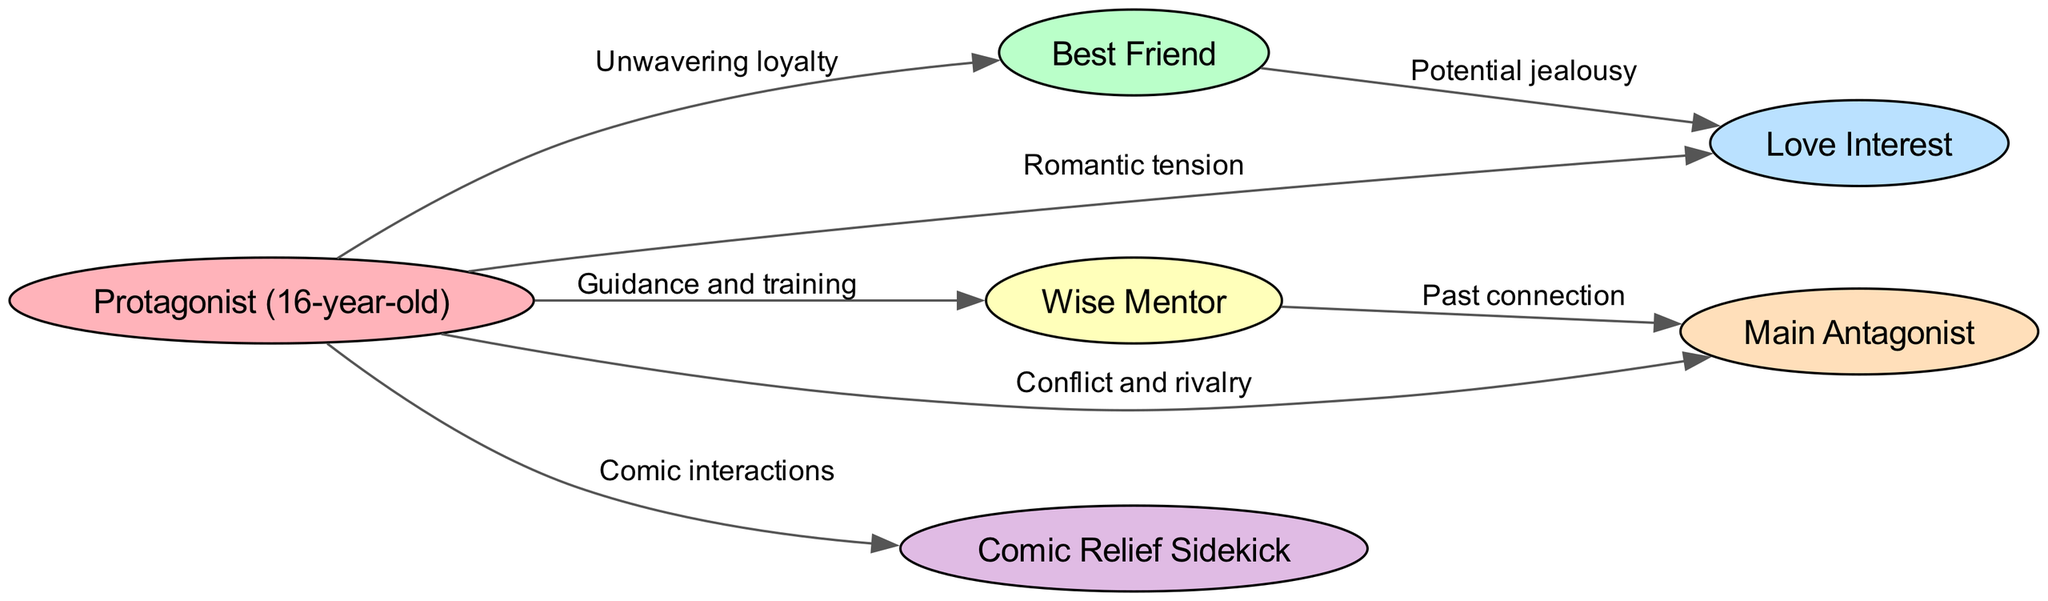What is the main relationship between the protagonist and the best friend? According to the diagram, the edge connecting the protagonist to the best friend is labeled "Unwavering loyalty," indicating that this is the primary nature of their relationship.
Answer: Unwavering loyalty How many nodes are present in the diagram? By counting the nodes listed in the data, there are six nodes: protagonist, best friend, love interest, mentor, antagonist, and sidekick. Therefore, the total number of nodes is six.
Answer: 6 What type of relationship exists between the protagonist and the love interest? The edge connecting the protagonist to the love interest is labeled "Romantic tension," which signifies the nature of their relationship.
Answer: Romantic tension Which character has a past connection with the antagonist? The edge from the mentor to the antagonist is labeled "Past connection," indicating that the mentor has a relationship tied to the antagonist.
Answer: Mentor How many edges are there in total? By examining the edges data, there are seven edges, each representing a relationship between characters; hence the total number is seven.
Answer: 7 What is the relationship between the best friend and the love interest? The edge connecting the best friend to the love interest is labeled "Potential jealousy," which defines their relationship in the context of the diagram.
Answer: Potential jealousy Why might the sidekick be important to the protagonist's journey? The edge labeled "Comic interactions" between the protagonist and the sidekick implies that their relationship adds humor and levity, which can be important for the protagonist's emotional journey.
Answer: Comic interactions Which character provides guidance and training to the protagonist? The edge from the mentor to the protagonist is labeled "Guidance and training," indicating that the mentor is the character who supports the protagonist's development.
Answer: Mentor What type of conflict exists between the protagonist and the antagonist? The label on the edge connecting the protagonist to the antagonist states "Conflict and rivalry," establishing that their relationship is centered around opposition.
Answer: Conflict and rivalry 